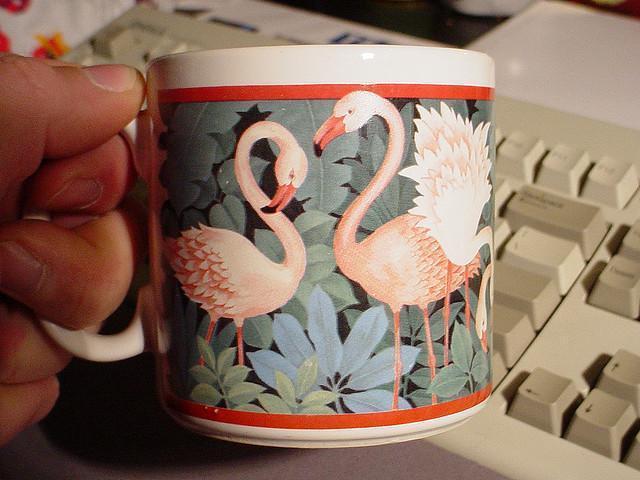How many birds are there?
Give a very brief answer. 2. How many keyboards are there?
Give a very brief answer. 1. 